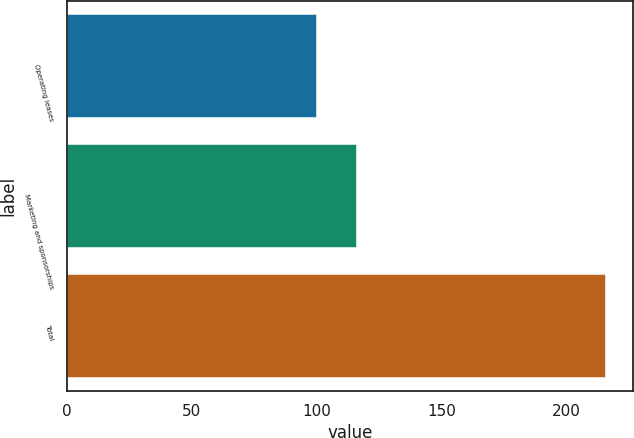<chart> <loc_0><loc_0><loc_500><loc_500><bar_chart><fcel>Operating leases<fcel>Marketing and sponsorships<fcel>Total<nl><fcel>100<fcel>116<fcel>216<nl></chart> 